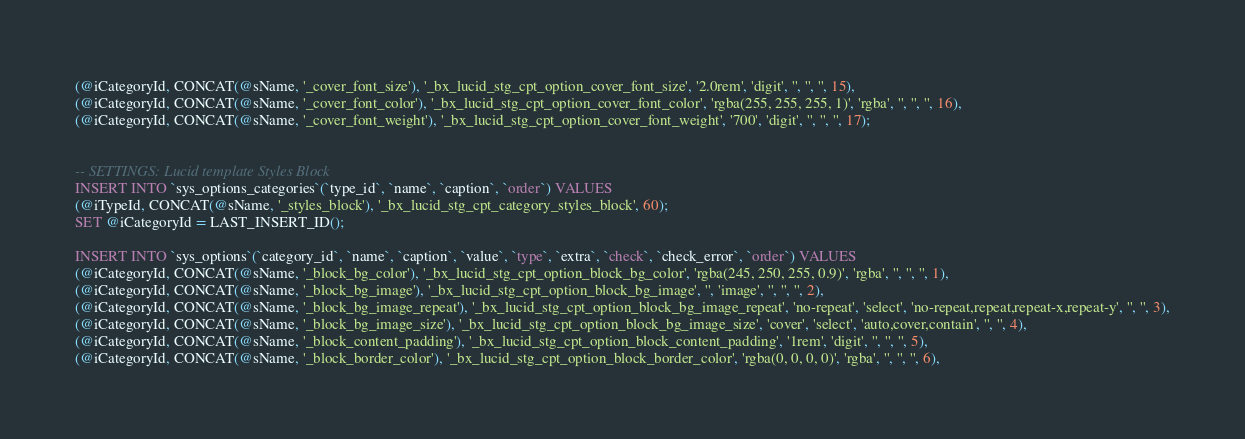Convert code to text. <code><loc_0><loc_0><loc_500><loc_500><_SQL_>(@iCategoryId, CONCAT(@sName, '_cover_font_size'), '_bx_lucid_stg_cpt_option_cover_font_size', '2.0rem', 'digit', '', '', '', 15),
(@iCategoryId, CONCAT(@sName, '_cover_font_color'), '_bx_lucid_stg_cpt_option_cover_font_color', 'rgba(255, 255, 255, 1)', 'rgba', '', '', '', 16),
(@iCategoryId, CONCAT(@sName, '_cover_font_weight'), '_bx_lucid_stg_cpt_option_cover_font_weight', '700', 'digit', '', '', '', 17);


-- SETTINGS: Lucid template Styles Block
INSERT INTO `sys_options_categories`(`type_id`, `name`, `caption`, `order`) VALUES 
(@iTypeId, CONCAT(@sName, '_styles_block'), '_bx_lucid_stg_cpt_category_styles_block', 60);
SET @iCategoryId = LAST_INSERT_ID();

INSERT INTO `sys_options`(`category_id`, `name`, `caption`, `value`, `type`, `extra`, `check`, `check_error`, `order`) VALUES
(@iCategoryId, CONCAT(@sName, '_block_bg_color'), '_bx_lucid_stg_cpt_option_block_bg_color', 'rgba(245, 250, 255, 0.9)', 'rgba', '', '', '', 1),
(@iCategoryId, CONCAT(@sName, '_block_bg_image'), '_bx_lucid_stg_cpt_option_block_bg_image', '', 'image', '', '', '', 2),
(@iCategoryId, CONCAT(@sName, '_block_bg_image_repeat'), '_bx_lucid_stg_cpt_option_block_bg_image_repeat', 'no-repeat', 'select', 'no-repeat,repeat,repeat-x,repeat-y', '', '', 3),
(@iCategoryId, CONCAT(@sName, '_block_bg_image_size'), '_bx_lucid_stg_cpt_option_block_bg_image_size', 'cover', 'select', 'auto,cover,contain', '', '', 4),
(@iCategoryId, CONCAT(@sName, '_block_content_padding'), '_bx_lucid_stg_cpt_option_block_content_padding', '1rem', 'digit', '', '', '', 5),
(@iCategoryId, CONCAT(@sName, '_block_border_color'), '_bx_lucid_stg_cpt_option_block_border_color', 'rgba(0, 0, 0, 0)', 'rgba', '', '', '', 6),</code> 